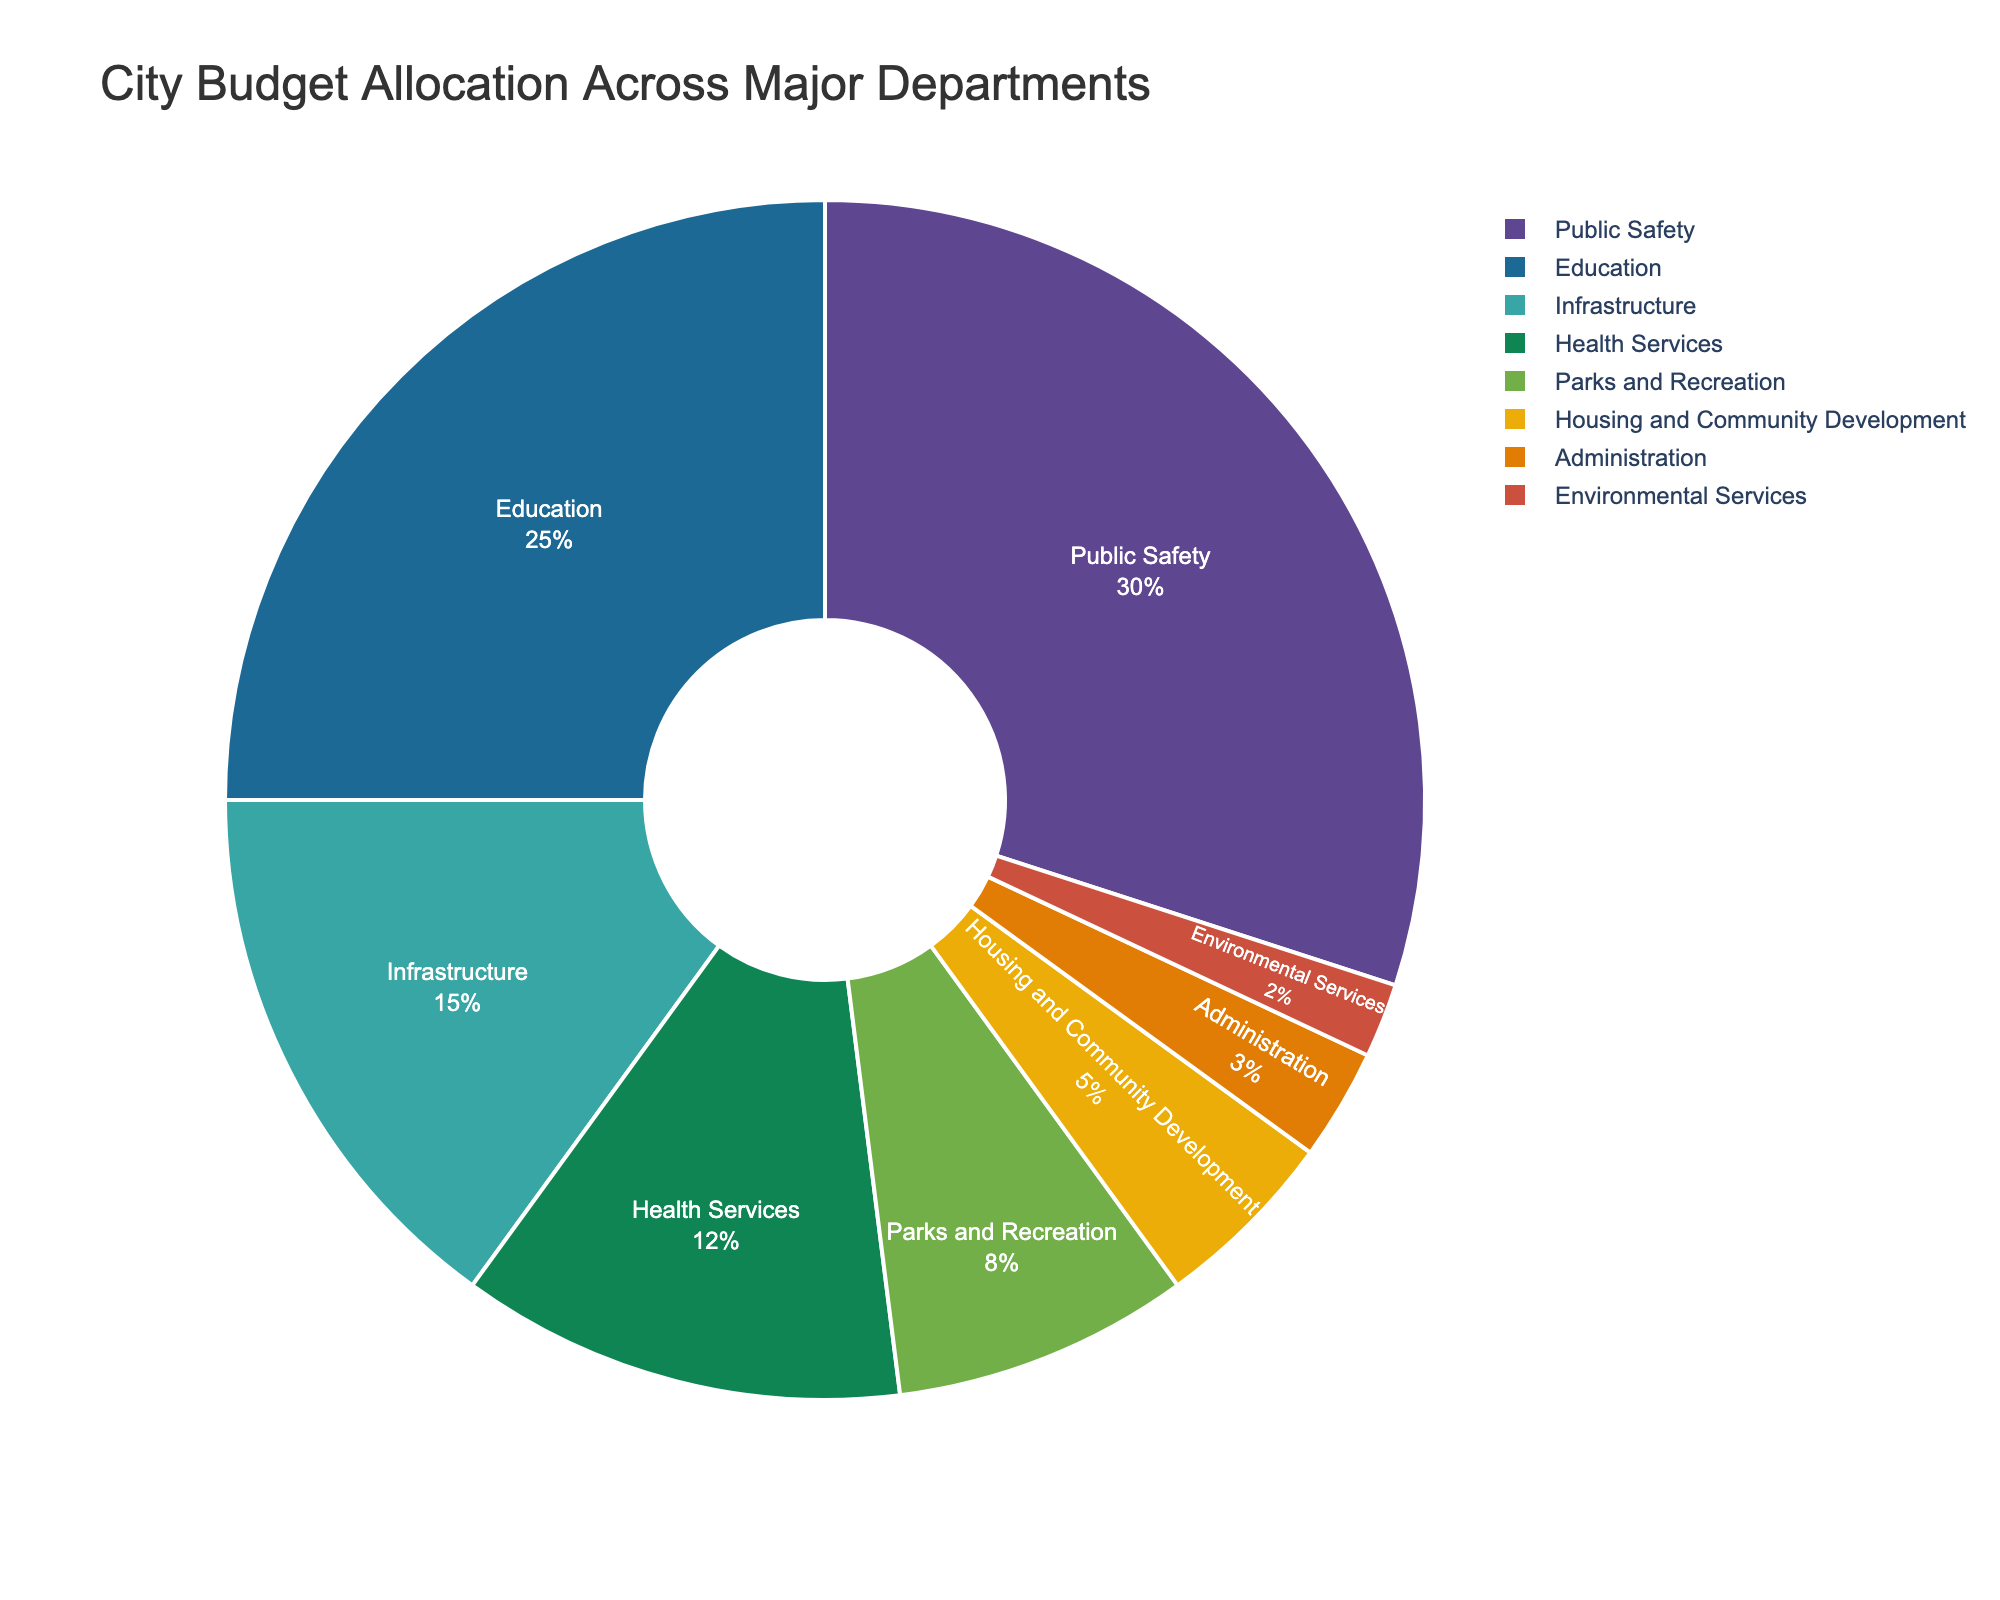What percentage of the budget is allocated to Public Safety? Public Safety's budget allocation is directly visible on the pie chart as a percentage.
Answer: 30% What is the combined budget allocation for Education and Health Services? Education's budget is 25%, and Health Services' budget is 12%. Adding these gives 25% + 12% = 37%.
Answer: 37% Which department has the smallest budget allocation? The department with the smallest budget allocation is directly visible as the smallest segment of the pie chart.
Answer: Environmental Services How much more budget is allocated to Public Safety compared to Parks and Recreation? Public Safety is allocated 30%, and Parks and Recreation is allocated 8%. The difference is 30% - 8% = 22%.
Answer: 22% What's the total budget percentage allocated to Infrastructure, Administration, and Environmental Services? Infrastructure is allocated 15%, Administration 3%, and Environmental Services 2%. Adding these gives 15% + 3% + 2% = 20%.
Answer: 20% Which department has a higher budget allocation, Housing and Community Development or Parks and Recreation? The pie chart shows that Parks and Recreation (8%) has a higher budget allocation compared to Housing and Community Development (5%).
Answer: Parks and Recreation How does the budget allocation for Health Services compare to the budget allocation for Infrastructure? The pie chart shows Health Services have 12% of the budget while Infrastructure has 15%. Therefore, Infrastructure has a higher allocation by 3%.
Answer: Infrastructure has 3% more What is the average budget allocation for Public Safety, Education, and Infrastructure? Public Safety has 30%, Education has 25%, and Infrastructure has 15%. The average is (30% + 25% + 15%)/3 = 70%/3 = 23.33%.
Answer: 23.33% Which department occupies a larger portion of the budget: Health Services or Housing and Community Development combined with Administration? Health Services has 12%, while Housing and Community Development (5%) and Administration (3%) combined have 5% + 3% = 8%. Thus, Health Services has a larger portion.
Answer: Health Services Are there any departments with equal budget allocations? By looking at the pie chart, it's evident that no two departments have the same allocation percentage.
Answer: No 